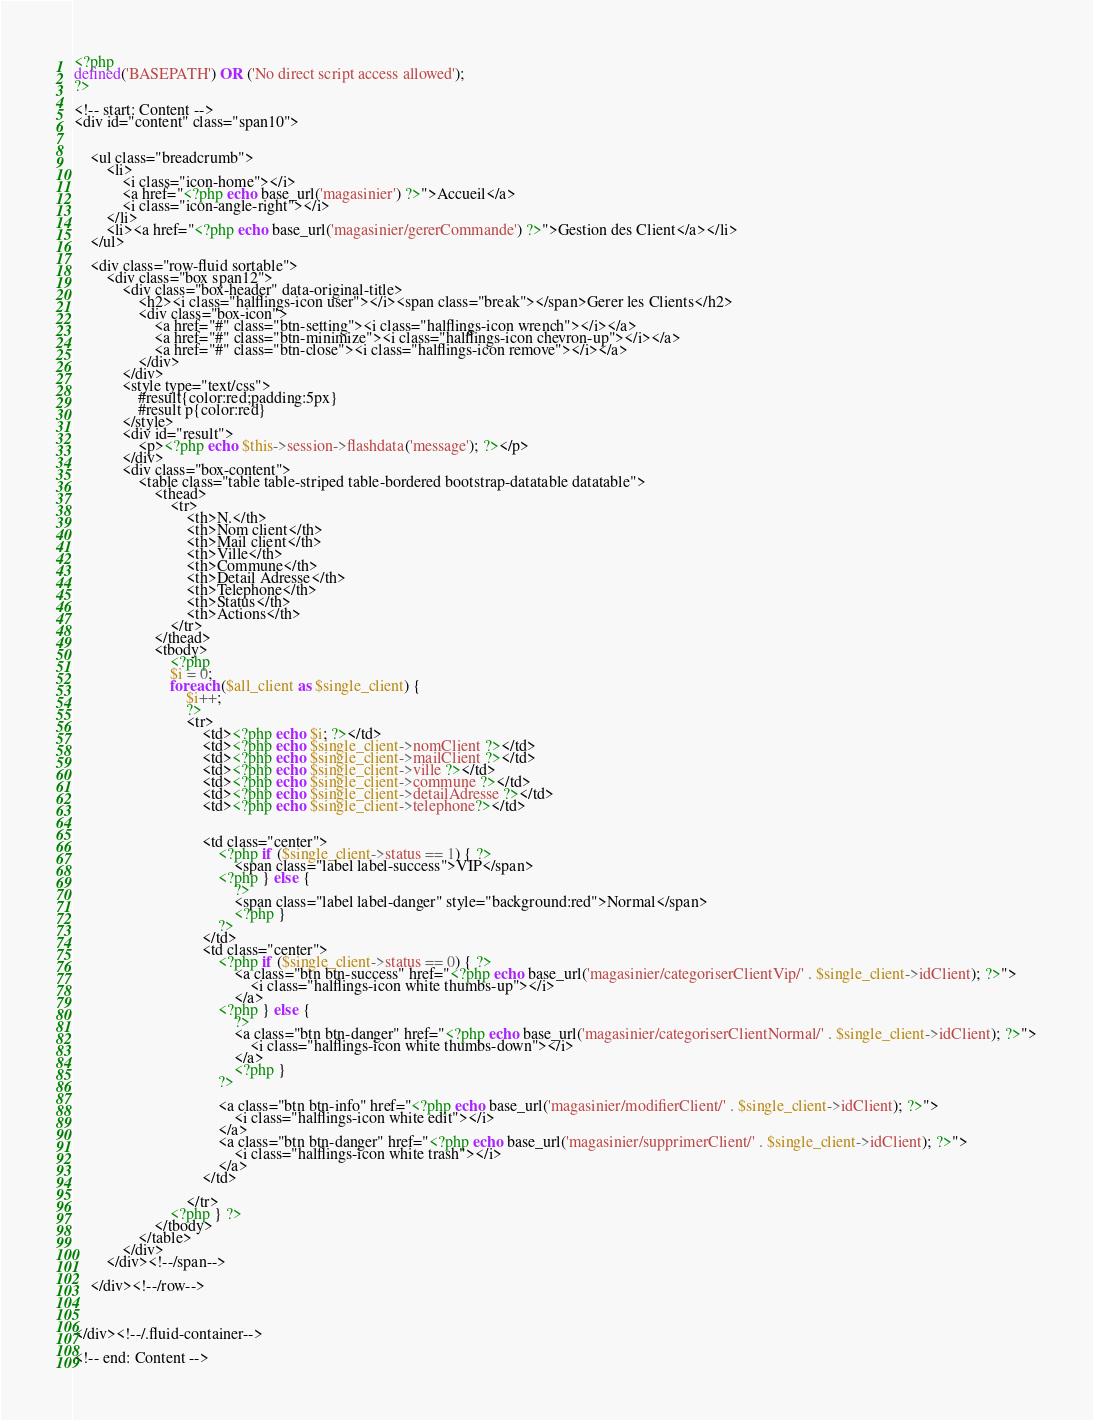Convert code to text. <code><loc_0><loc_0><loc_500><loc_500><_PHP_><?php
defined('BASEPATH') OR ('No direct script access allowed');
?>

<!-- start: Content -->
<div id="content" class="span10">


    <ul class="breadcrumb">
        <li>
            <i class="icon-home"></i>
            <a href="<?php echo base_url('magasinier') ?>">Accueil</a> 
            <i class="icon-angle-right"></i>
        </li>
        <li><a href="<?php echo base_url('magasinier/gererCommande') ?>">Gestion des Client</a></li>
    </ul>

    <div class="row-fluid sortable">		
        <div class="box span12">
            <div class="box-header" data-original-title>
                <h2><i class="halflings-icon user"></i><span class="break"></span>Gerer les Clients</h2>
                <div class="box-icon">
                    <a href="#" class="btn-setting"><i class="halflings-icon wrench"></i></a>
                    <a href="#" class="btn-minimize"><i class="halflings-icon chevron-up"></i></a>
                    <a href="#" class="btn-close"><i class="halflings-icon remove"></i></a>
                </div>
            </div>
            <style type="text/css">
                #result{color:red;padding:5px}
                #result p{color:red}
            </style>
            <div id="result">
                <p><?php echo $this->session->flashdata('message'); ?></p>
            </div>
            <div class="box-content">
                <table class="table table-striped table-bordered bootstrap-datatable datatable">
                    <thead>
                        <tr>
                            <th>N.</th>
                            <th>Nom client</th>
                            <th>Mail client</th>
                            <th>Ville</th>
                            <th>Commune</th>
                            <th>Detail Adresse</th>
                            <th>Telephone</th>
                            <th>Status</th>
                            <th>Actions</th>
                        </tr>
                    </thead>   
                    <tbody>
                        <?php
                        $i = 0;
                        foreach ($all_client as $single_client) {
                            $i++;
                            ?>
                            <tr>
                                <td><?php echo $i; ?></td>
                                <td><?php echo $single_client->nomClient ?></td>
                                <td><?php echo $single_client->mailClient ?></td>
                                <td><?php echo $single_client->ville ?></td>
                                <td><?php echo $single_client->commune ?></td>
                                <td><?php echo $single_client->detailAdresse ?></td>
                                <td><?php echo $single_client->telephone?></td>
                                

                                <td class="center">
                                    <?php if ($single_client->status == 1) { ?>
                                        <span class="label label-success">VIP</span>
                                    <?php } else {
                                        ?>
                                        <span class="label label-danger" style="background:red">Normal</span>
                                        <?php }
                                    ?>
                                </td>
                                <td class="center">
                                    <?php if ($single_client->status == 0) { ?>
                                        <a class="btn btn-success" href="<?php echo base_url('magasinier/categoriserClientVip/' . $single_client->idClient); ?>">
                                            <i class="halflings-icon white thumbs-up"></i>  
                                        </a>
                                    <?php } else {
                                        ?>
                                        <a class="btn btn-danger" href="<?php echo base_url('magasinier/categoriserClientNormal/' . $single_client->idClient); ?>">
                                            <i class="halflings-icon white thumbs-down"></i>  
                                        </a>
                                        <?php }
                                    ?>

                                    <a class="btn btn-info" href="<?php echo base_url('magasinier/modifierClient/' . $single_client->idClient); ?>">
                                        <i class="halflings-icon white edit"></i>  
                                    </a>
                                    <a class="btn btn-danger" href="<?php echo base_url('magasinier/supprimerClient/' . $single_client->idClient); ?>">
                                        <i class="halflings-icon white trash"></i> 
                                    </a>
                                </td>

                            </tr>
                        <?php } ?>
                    </tbody>
                </table>            
            </div>
        </div><!--/span-->

    </div><!--/row-->



</div><!--/.fluid-container-->

<!-- end: Content --></code> 